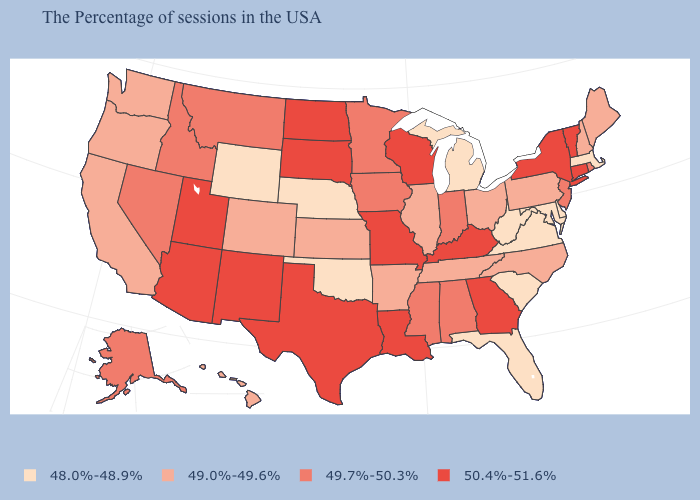Name the states that have a value in the range 49.0%-49.6%?
Quick response, please. Maine, New Hampshire, Pennsylvania, North Carolina, Ohio, Tennessee, Illinois, Arkansas, Kansas, Colorado, California, Washington, Oregon, Hawaii. Among the states that border Colorado , which have the lowest value?
Concise answer only. Nebraska, Oklahoma, Wyoming. What is the value of Alaska?
Answer briefly. 49.7%-50.3%. Does Pennsylvania have a higher value than Delaware?
Concise answer only. Yes. Is the legend a continuous bar?
Concise answer only. No. Does Nebraska have the lowest value in the MidWest?
Keep it brief. Yes. Which states have the lowest value in the West?
Answer briefly. Wyoming. Which states have the lowest value in the USA?
Give a very brief answer. Massachusetts, Delaware, Maryland, Virginia, South Carolina, West Virginia, Florida, Michigan, Nebraska, Oklahoma, Wyoming. Among the states that border New Mexico , does Oklahoma have the lowest value?
Short answer required. Yes. Is the legend a continuous bar?
Keep it brief. No. What is the value of Massachusetts?
Be succinct. 48.0%-48.9%. What is the value of Oregon?
Concise answer only. 49.0%-49.6%. What is the value of Virginia?
Be succinct. 48.0%-48.9%. What is the highest value in the MidWest ?
Quick response, please. 50.4%-51.6%. What is the highest value in the MidWest ?
Short answer required. 50.4%-51.6%. 